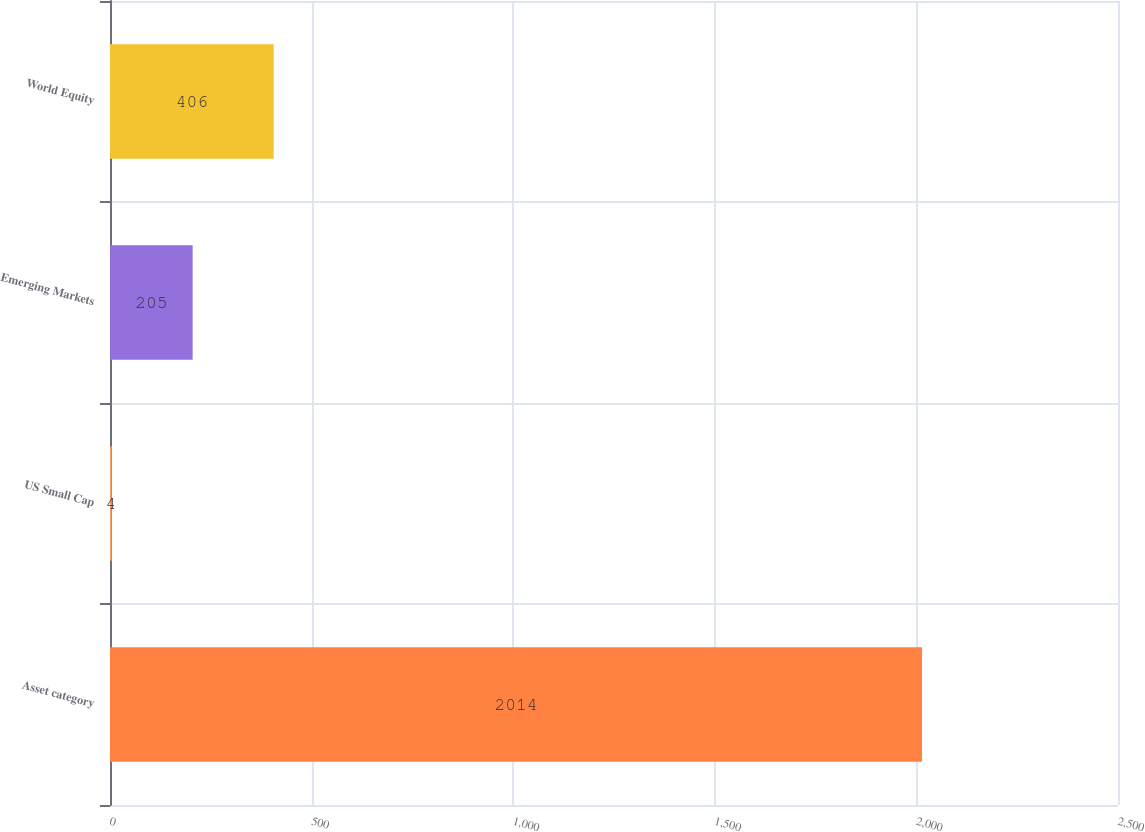<chart> <loc_0><loc_0><loc_500><loc_500><bar_chart><fcel>Asset category<fcel>US Small Cap<fcel>Emerging Markets<fcel>World Equity<nl><fcel>2014<fcel>4<fcel>205<fcel>406<nl></chart> 